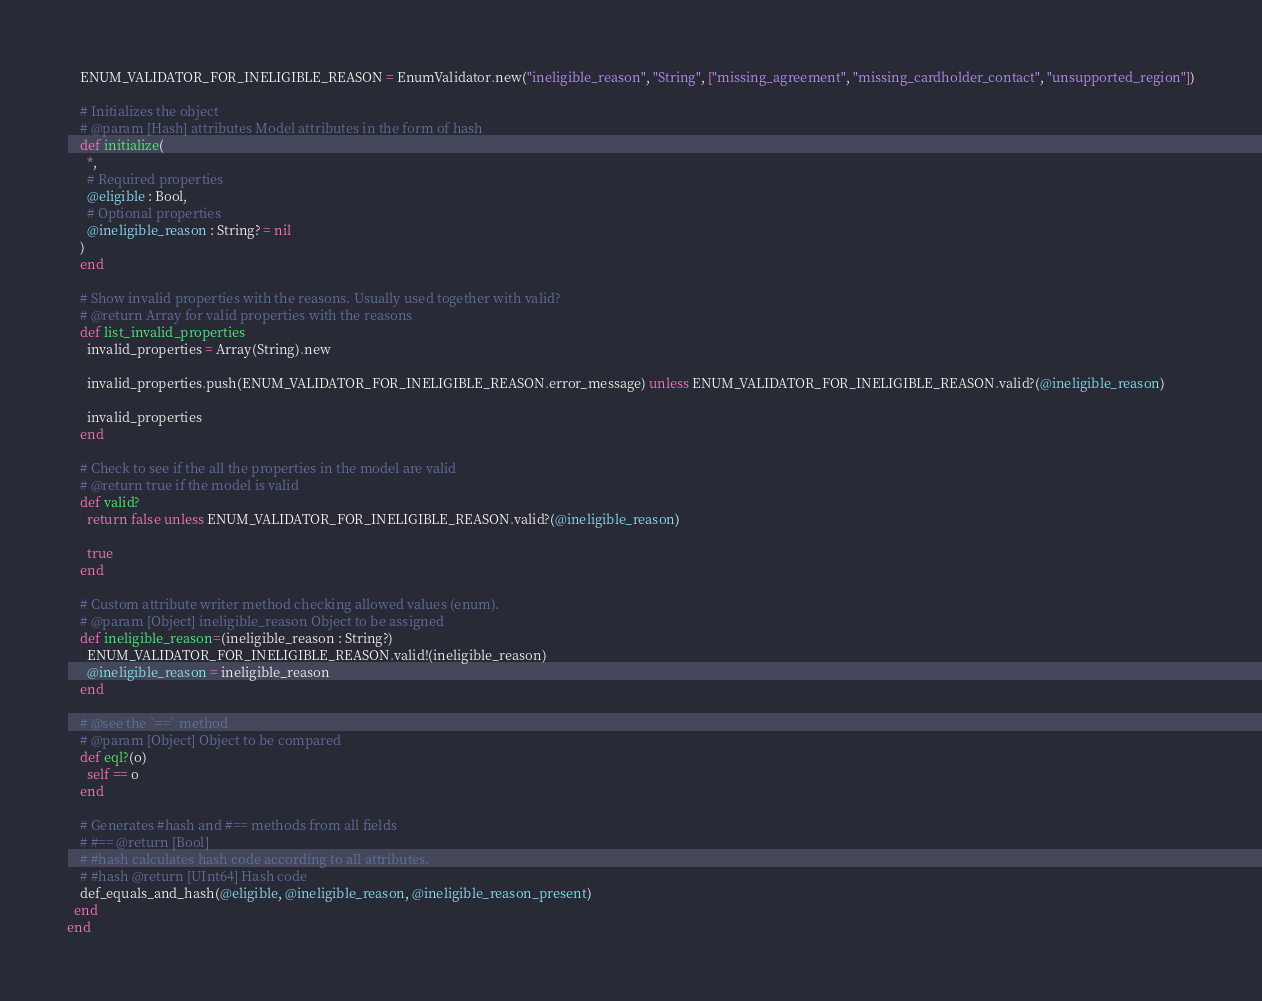Convert code to text. <code><loc_0><loc_0><loc_500><loc_500><_Crystal_>    ENUM_VALIDATOR_FOR_INELIGIBLE_REASON = EnumValidator.new("ineligible_reason", "String", ["missing_agreement", "missing_cardholder_contact", "unsupported_region"])

    # Initializes the object
    # @param [Hash] attributes Model attributes in the form of hash
    def initialize(
      *,
      # Required properties
      @eligible : Bool,
      # Optional properties
      @ineligible_reason : String? = nil
    )
    end

    # Show invalid properties with the reasons. Usually used together with valid?
    # @return Array for valid properties with the reasons
    def list_invalid_properties
      invalid_properties = Array(String).new

      invalid_properties.push(ENUM_VALIDATOR_FOR_INELIGIBLE_REASON.error_message) unless ENUM_VALIDATOR_FOR_INELIGIBLE_REASON.valid?(@ineligible_reason)

      invalid_properties
    end

    # Check to see if the all the properties in the model are valid
    # @return true if the model is valid
    def valid?
      return false unless ENUM_VALIDATOR_FOR_INELIGIBLE_REASON.valid?(@ineligible_reason)

      true
    end

    # Custom attribute writer method checking allowed values (enum).
    # @param [Object] ineligible_reason Object to be assigned
    def ineligible_reason=(ineligible_reason : String?)
      ENUM_VALIDATOR_FOR_INELIGIBLE_REASON.valid!(ineligible_reason)
      @ineligible_reason = ineligible_reason
    end

    # @see the `==` method
    # @param [Object] Object to be compared
    def eql?(o)
      self == o
    end

    # Generates #hash and #== methods from all fields
    # #== @return [Bool]
    # #hash calculates hash code according to all attributes.
    # #hash @return [UInt64] Hash code
    def_equals_and_hash(@eligible, @ineligible_reason, @ineligible_reason_present)
  end
end
</code> 